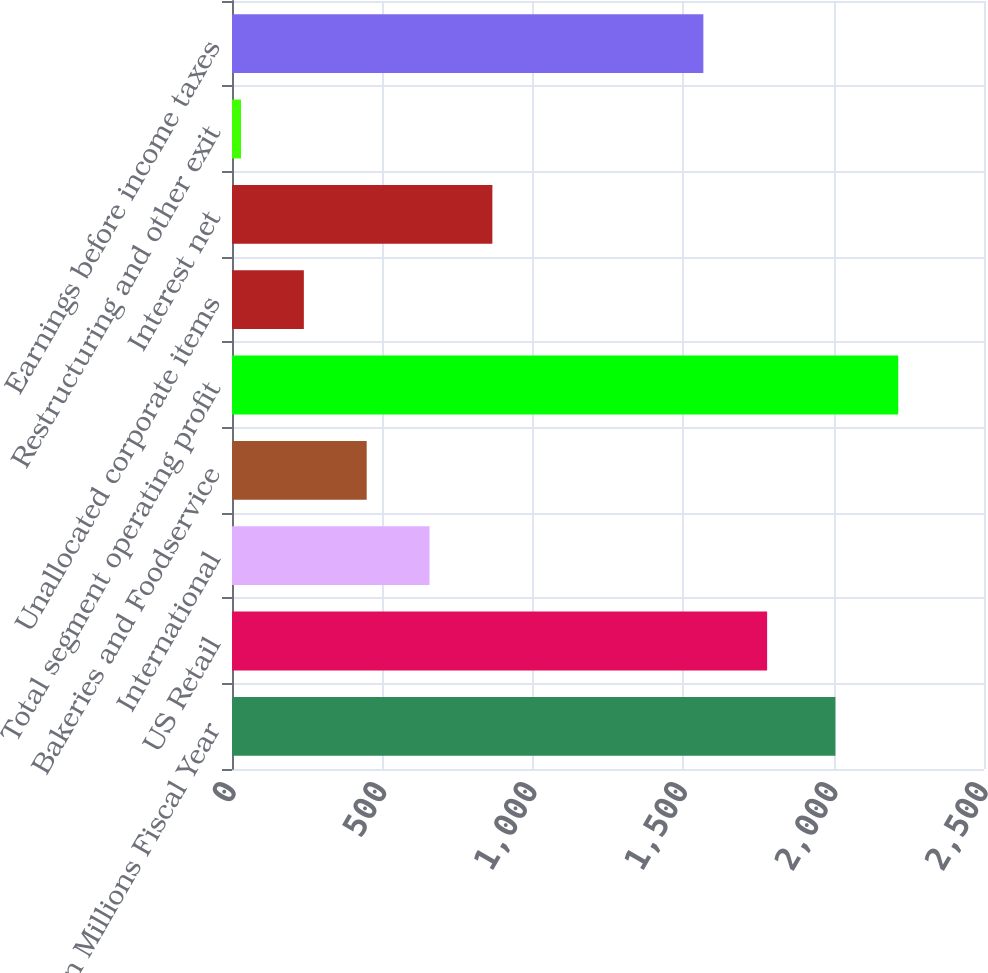<chart> <loc_0><loc_0><loc_500><loc_500><bar_chart><fcel>In Millions Fiscal Year<fcel>US Retail<fcel>International<fcel>Bakeries and Foodservice<fcel>Total segment operating profit<fcel>Unallocated corporate items<fcel>Interest net<fcel>Restructuring and other exit<fcel>Earnings before income taxes<nl><fcel>2006<fcel>1779<fcel>656.7<fcel>447.8<fcel>2214.9<fcel>238.9<fcel>865.6<fcel>30<fcel>1567<nl></chart> 